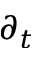<formula> <loc_0><loc_0><loc_500><loc_500>\partial _ { t }</formula> 